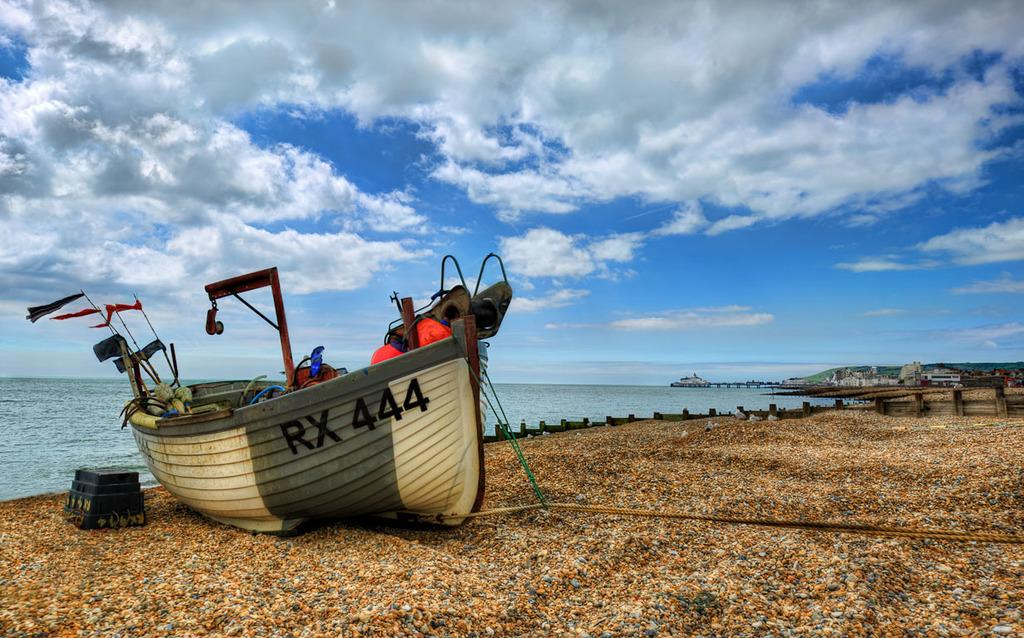<image>
Provide a brief description of the given image. Green and white boat which says RX444 on it. 